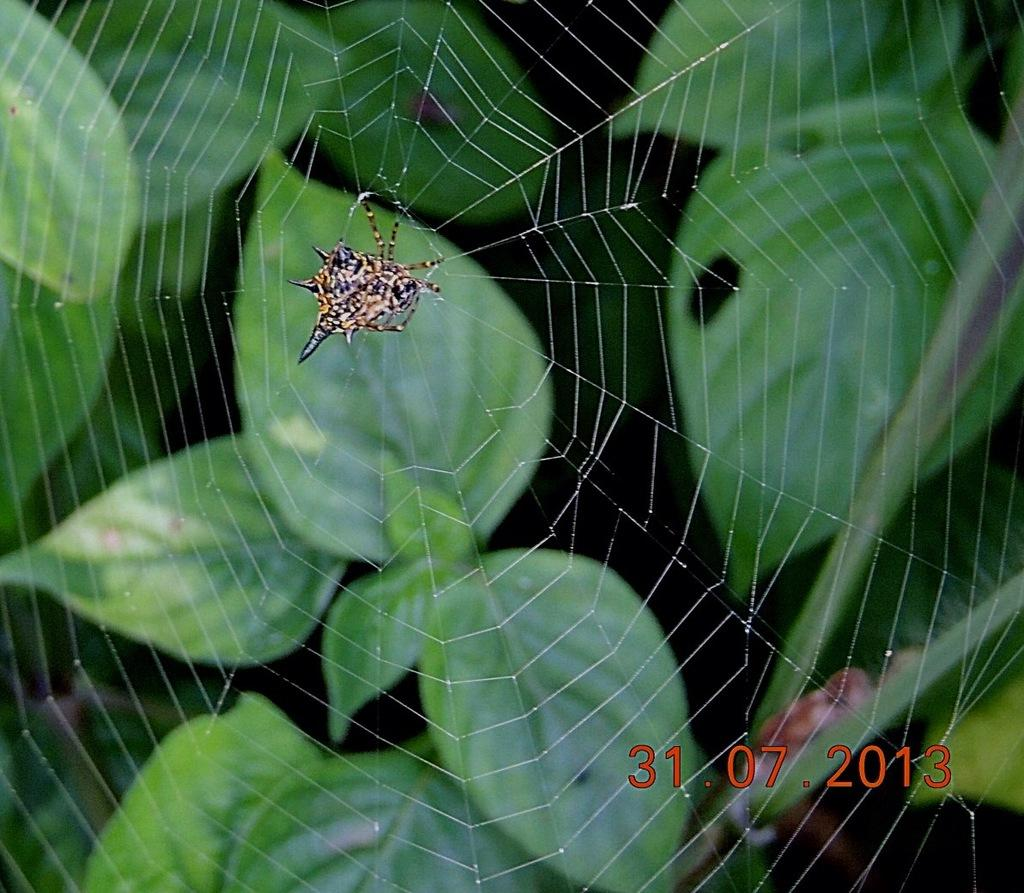What type of insect is present in the image? There is a spider insect in the image. What type of vegetation is visible in the image? There are leaves in the image. What type of list can be seen hanging from the spider's web in the image? There is no list present in the image; it features a spider insect and leaves. How does the spider push the leaves in the image? The spider does not push the leaves in the image; it is stationary on its web. 